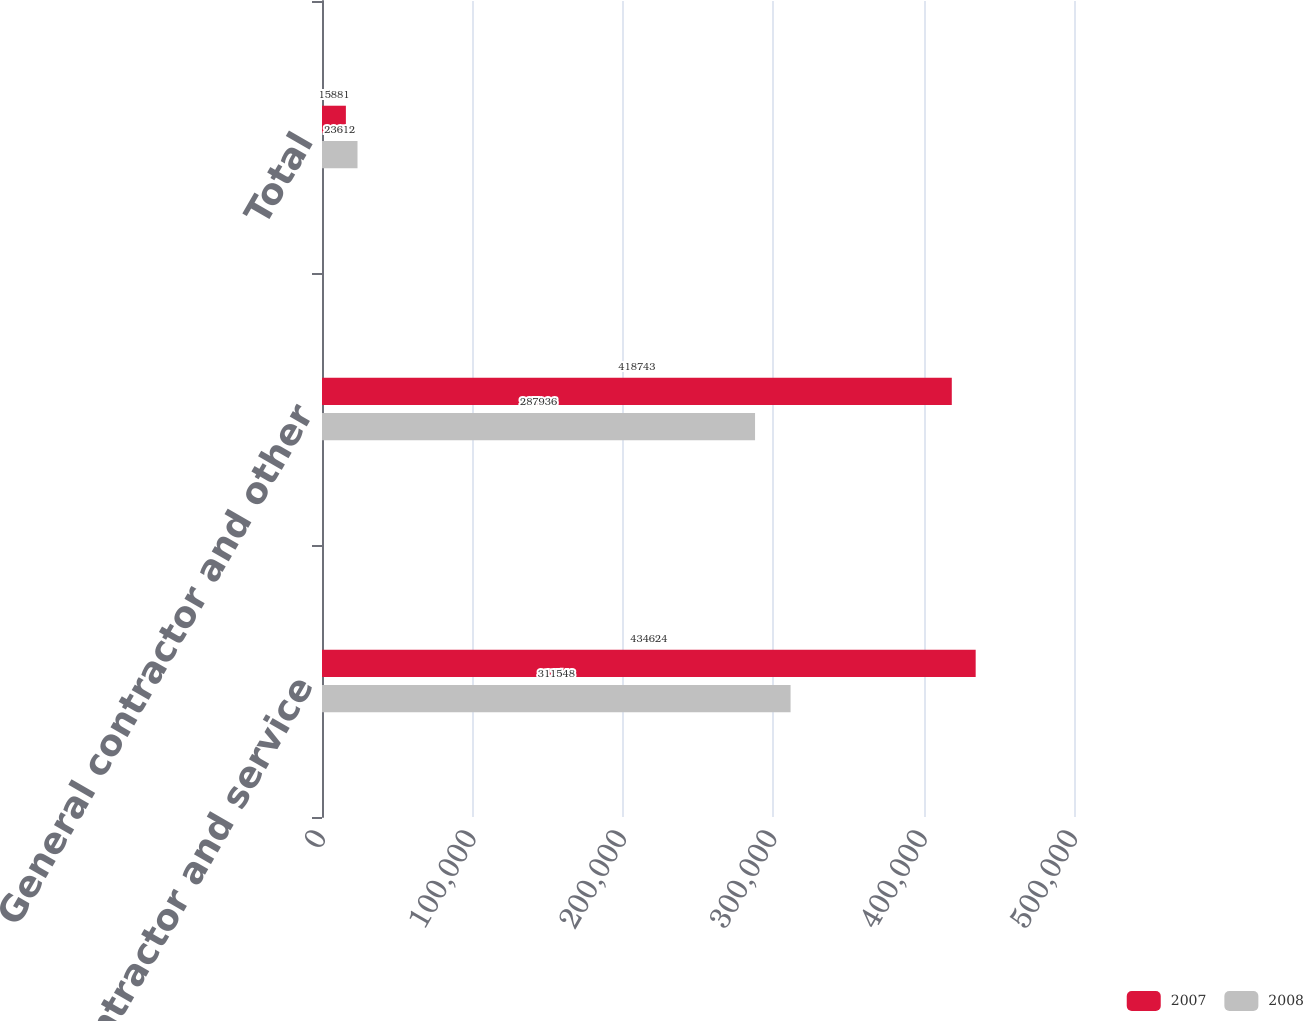<chart> <loc_0><loc_0><loc_500><loc_500><stacked_bar_chart><ecel><fcel>General contractor and service<fcel>General contractor and other<fcel>Total<nl><fcel>2007<fcel>434624<fcel>418743<fcel>15881<nl><fcel>2008<fcel>311548<fcel>287936<fcel>23612<nl></chart> 